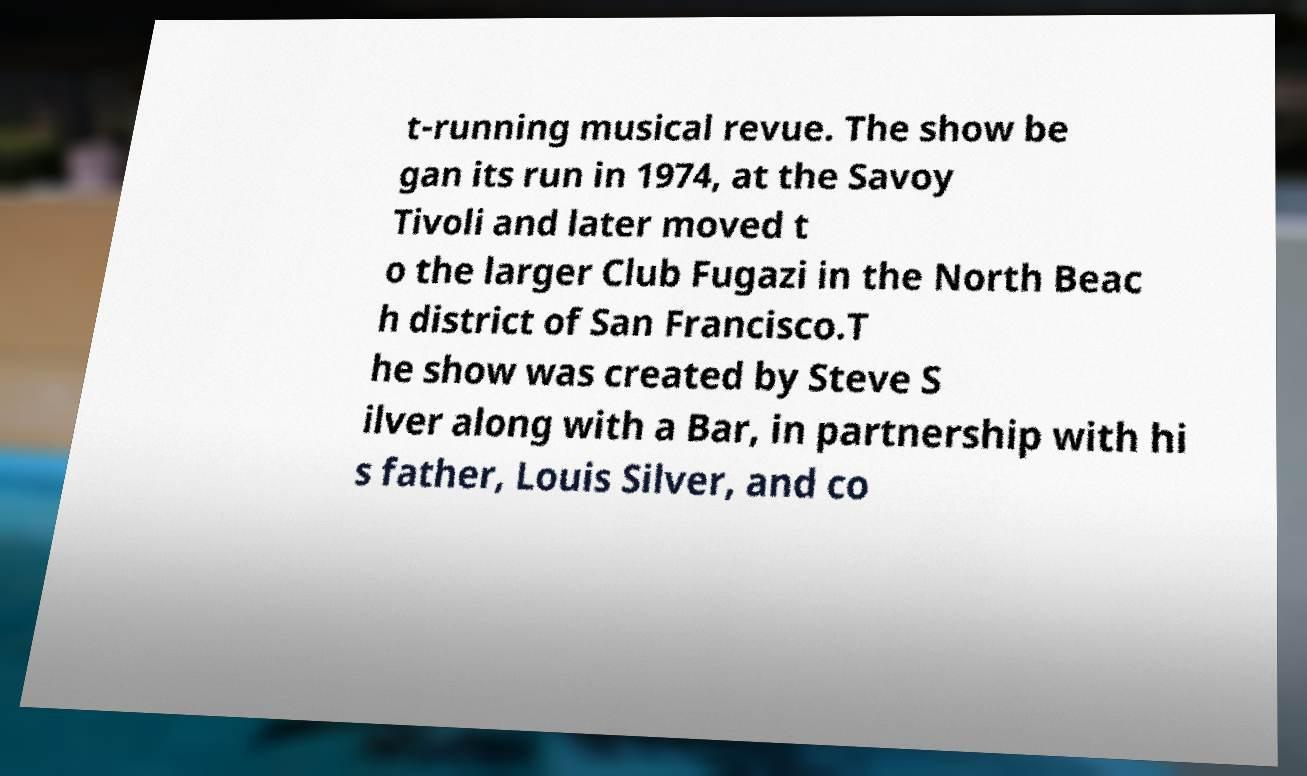Please read and relay the text visible in this image. What does it say? t-running musical revue. The show be gan its run in 1974, at the Savoy Tivoli and later moved t o the larger Club Fugazi in the North Beac h district of San Francisco.T he show was created by Steve S ilver along with a Bar, in partnership with hi s father, Louis Silver, and co 